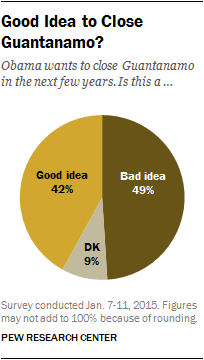Specify some key components in this picture. The value difference between a good idea and a bad idea is 7. According to a survey, 0.42 out of the total respondents agree with the idea proposed by President Obama. 